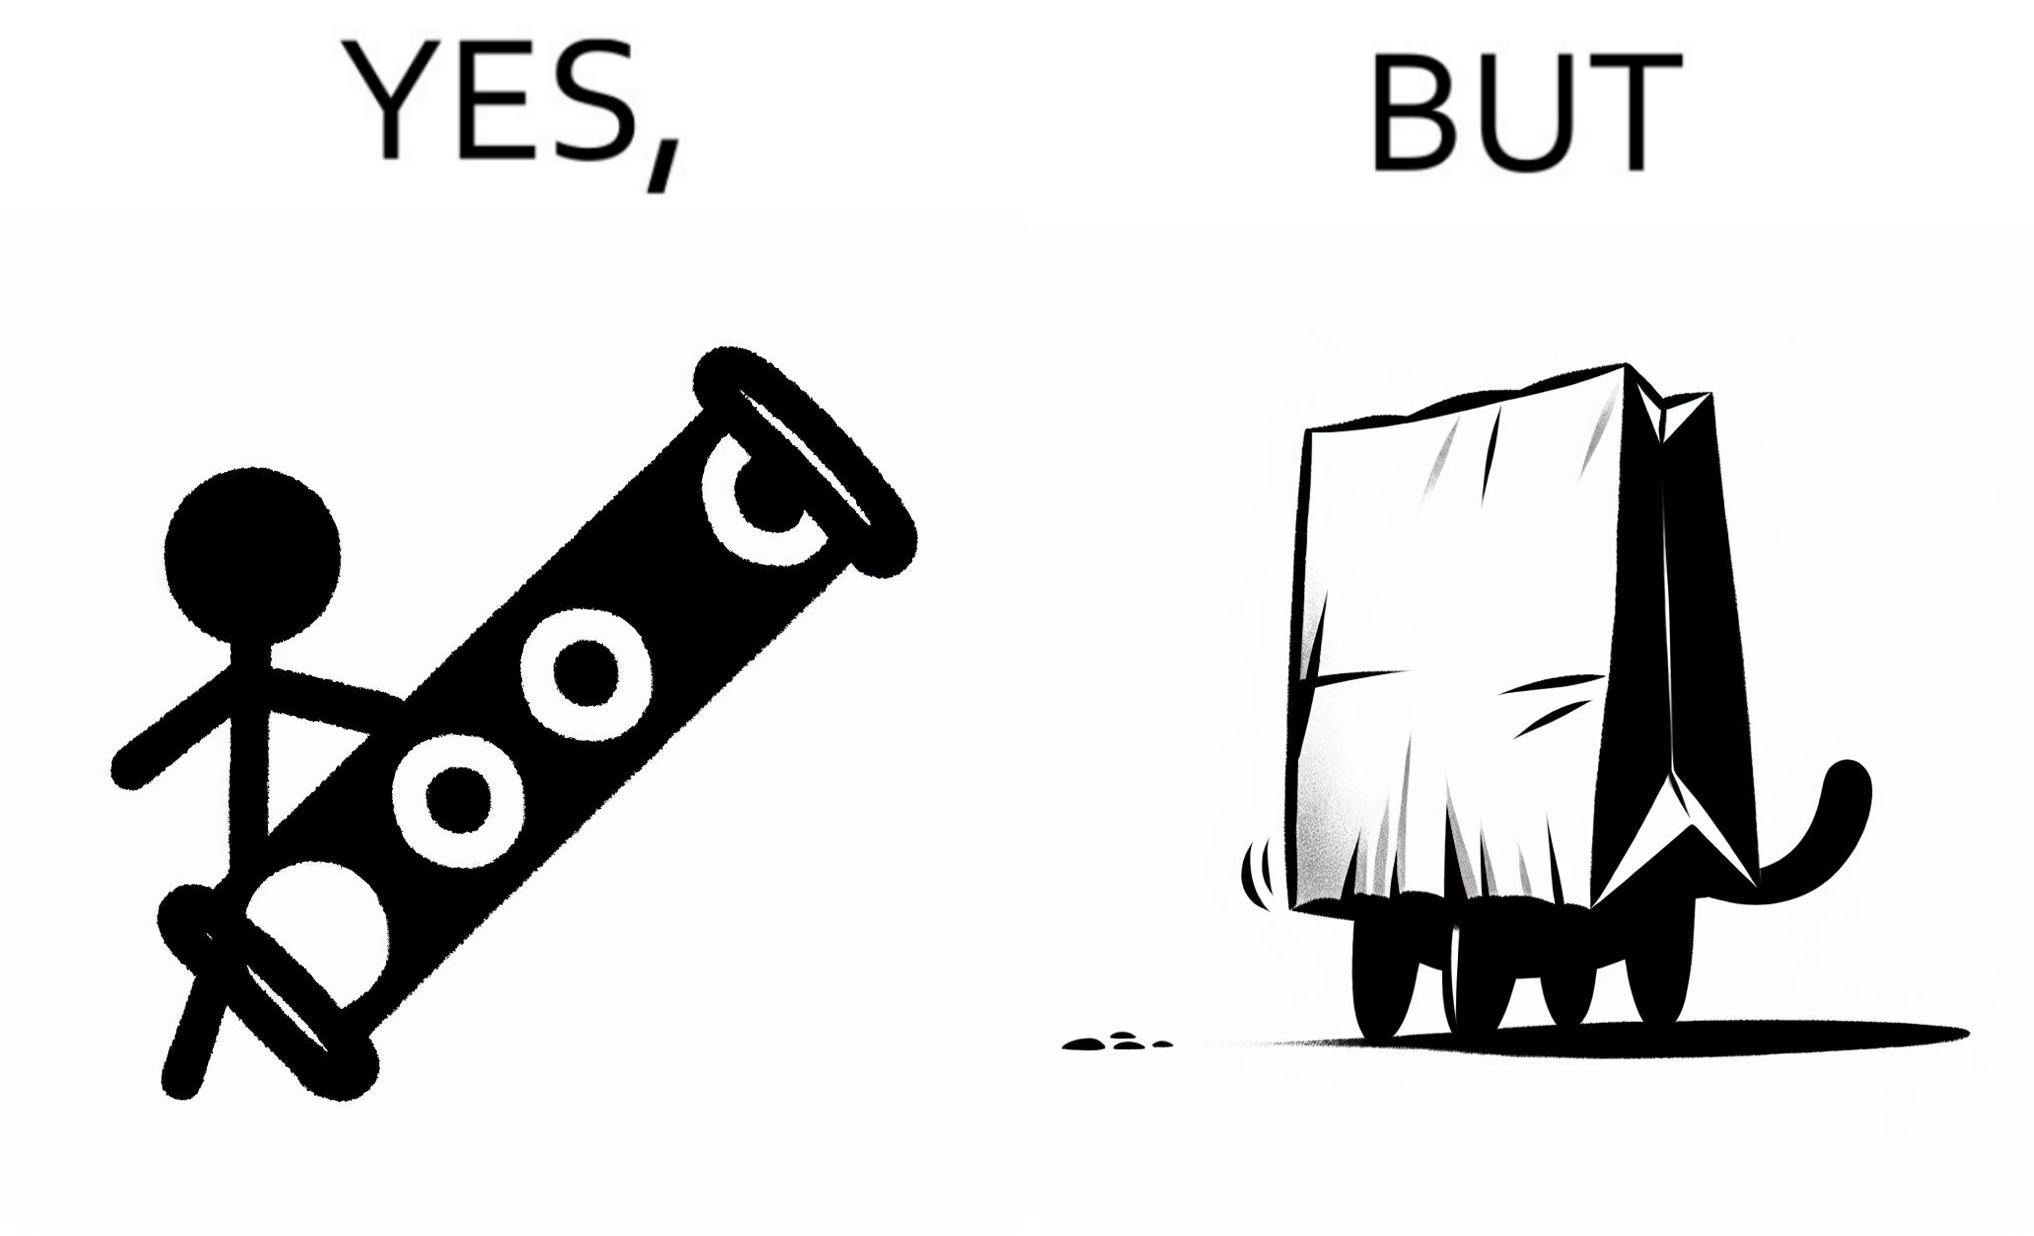Explain the humor or irony in this image. The image is funny, because even when there is a dedicated thing for the animal to play with it still is hiding itself in the paper bag 